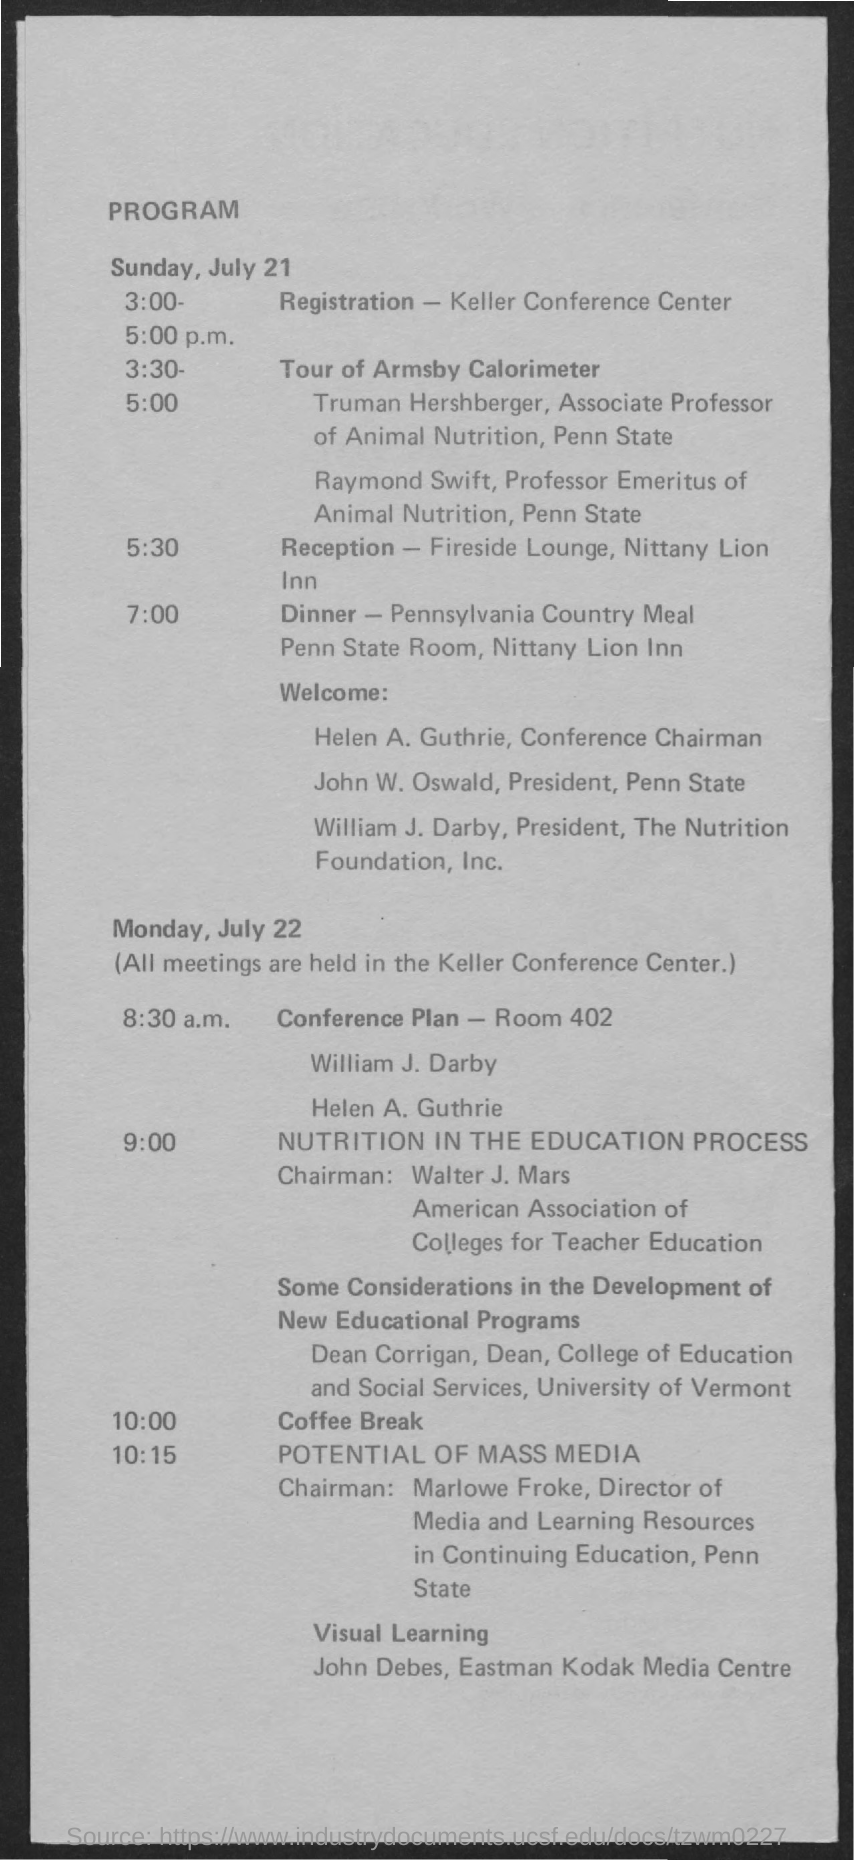What is the title of the document?
Give a very brief answer. PROGRAM. Coffee Break is on which time?
Provide a short and direct response. 10:00. Reception is on which time?
Your answer should be compact. 5:30. What is the first date mentioned in the document?
Provide a succinct answer. JULY 21. What is the second date mentioned in the document?
Your response must be concise. Monday, July 22. 